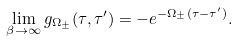Convert formula to latex. <formula><loc_0><loc_0><loc_500><loc_500>\lim _ { \beta \to \infty } g _ { \Omega _ { \pm } } ( \tau , \tau ^ { \prime } ) = - e ^ { - \Omega _ { \pm } ( \tau - \tau ^ { \prime } ) } .</formula> 